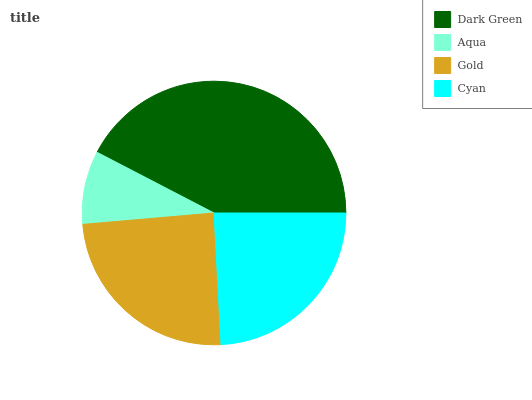Is Aqua the minimum?
Answer yes or no. Yes. Is Dark Green the maximum?
Answer yes or no. Yes. Is Gold the minimum?
Answer yes or no. No. Is Gold the maximum?
Answer yes or no. No. Is Gold greater than Aqua?
Answer yes or no. Yes. Is Aqua less than Gold?
Answer yes or no. Yes. Is Aqua greater than Gold?
Answer yes or no. No. Is Gold less than Aqua?
Answer yes or no. No. Is Gold the high median?
Answer yes or no. Yes. Is Cyan the low median?
Answer yes or no. Yes. Is Aqua the high median?
Answer yes or no. No. Is Aqua the low median?
Answer yes or no. No. 